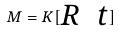Convert formula to latex. <formula><loc_0><loc_0><loc_500><loc_500>M = K [ \begin{matrix} R & t \end{matrix} ]</formula> 